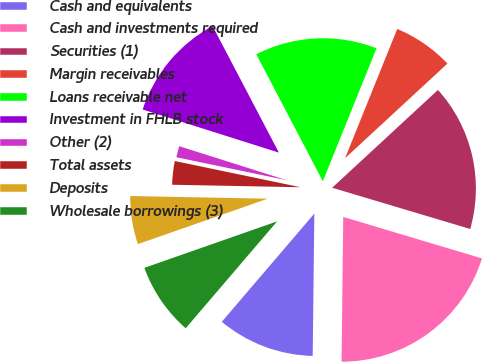Convert chart to OTSL. <chart><loc_0><loc_0><loc_500><loc_500><pie_chart><fcel>Cash and equivalents<fcel>Cash and investments required<fcel>Securities (1)<fcel>Margin receivables<fcel>Loans receivable net<fcel>Investment in FHLB stock<fcel>Other (2)<fcel>Total assets<fcel>Deposits<fcel>Wholesale borrowings (3)<nl><fcel>11.08%<fcel>20.56%<fcel>16.5%<fcel>7.02%<fcel>13.79%<fcel>12.44%<fcel>1.61%<fcel>2.96%<fcel>5.67%<fcel>8.38%<nl></chart> 